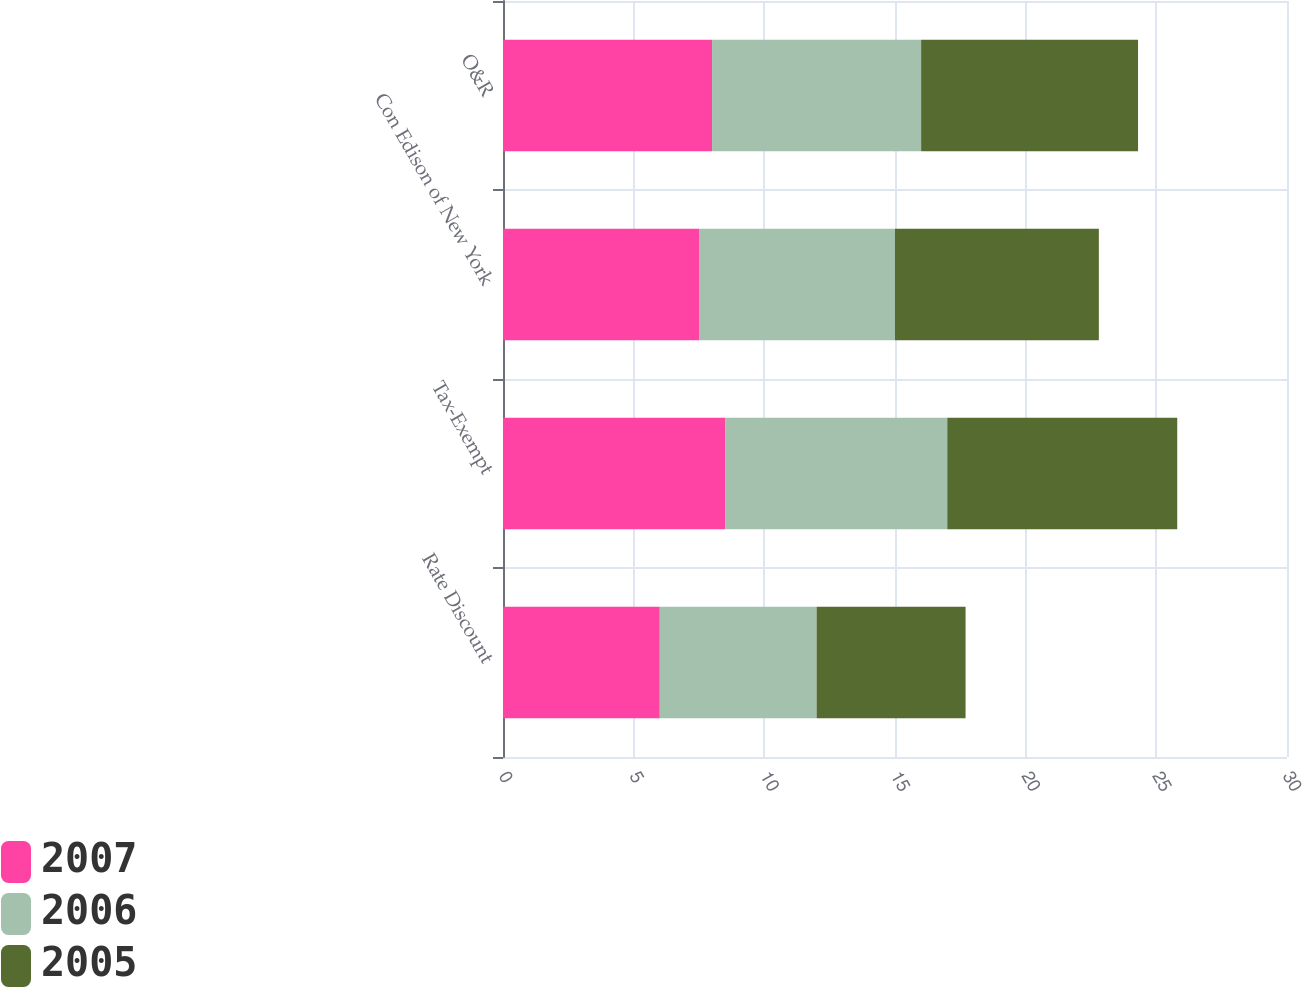<chart> <loc_0><loc_0><loc_500><loc_500><stacked_bar_chart><ecel><fcel>Rate Discount<fcel>Tax-Exempt<fcel>Con Edison of New York<fcel>O&R<nl><fcel>2007<fcel>6<fcel>8.5<fcel>7.5<fcel>8<nl><fcel>2006<fcel>6<fcel>8.5<fcel>7.5<fcel>8<nl><fcel>2005<fcel>5.7<fcel>8.8<fcel>7.8<fcel>8.3<nl></chart> 